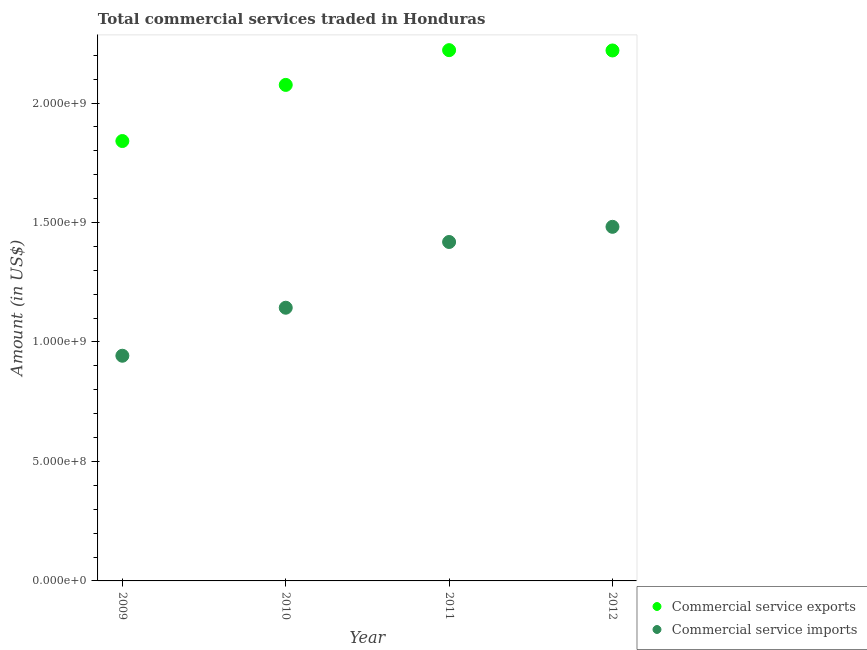How many different coloured dotlines are there?
Ensure brevity in your answer.  2. Is the number of dotlines equal to the number of legend labels?
Ensure brevity in your answer.  Yes. What is the amount of commercial service exports in 2012?
Offer a terse response. 2.22e+09. Across all years, what is the maximum amount of commercial service imports?
Your answer should be very brief. 1.48e+09. Across all years, what is the minimum amount of commercial service imports?
Give a very brief answer. 9.42e+08. In which year was the amount of commercial service exports maximum?
Ensure brevity in your answer.  2011. In which year was the amount of commercial service imports minimum?
Give a very brief answer. 2009. What is the total amount of commercial service imports in the graph?
Offer a very short reply. 4.99e+09. What is the difference between the amount of commercial service imports in 2009 and that in 2012?
Your response must be concise. -5.39e+08. What is the difference between the amount of commercial service exports in 2010 and the amount of commercial service imports in 2012?
Your answer should be very brief. 5.94e+08. What is the average amount of commercial service exports per year?
Your response must be concise. 2.09e+09. In the year 2009, what is the difference between the amount of commercial service exports and amount of commercial service imports?
Your response must be concise. 8.99e+08. In how many years, is the amount of commercial service exports greater than 1400000000 US$?
Your answer should be very brief. 4. What is the ratio of the amount of commercial service exports in 2011 to that in 2012?
Your response must be concise. 1. Is the amount of commercial service exports in 2010 less than that in 2012?
Ensure brevity in your answer.  Yes. Is the difference between the amount of commercial service exports in 2009 and 2012 greater than the difference between the amount of commercial service imports in 2009 and 2012?
Offer a very short reply. Yes. What is the difference between the highest and the second highest amount of commercial service imports?
Your answer should be compact. 6.34e+07. What is the difference between the highest and the lowest amount of commercial service imports?
Keep it short and to the point. 5.39e+08. In how many years, is the amount of commercial service exports greater than the average amount of commercial service exports taken over all years?
Provide a succinct answer. 2. How many dotlines are there?
Make the answer very short. 2. Are the values on the major ticks of Y-axis written in scientific E-notation?
Offer a terse response. Yes. Does the graph contain grids?
Your answer should be very brief. No. Where does the legend appear in the graph?
Give a very brief answer. Bottom right. How many legend labels are there?
Keep it short and to the point. 2. What is the title of the graph?
Offer a very short reply. Total commercial services traded in Honduras. Does "Registered firms" appear as one of the legend labels in the graph?
Give a very brief answer. No. What is the label or title of the Y-axis?
Offer a terse response. Amount (in US$). What is the Amount (in US$) of Commercial service exports in 2009?
Your answer should be very brief. 1.84e+09. What is the Amount (in US$) of Commercial service imports in 2009?
Provide a succinct answer. 9.42e+08. What is the Amount (in US$) in Commercial service exports in 2010?
Your answer should be compact. 2.08e+09. What is the Amount (in US$) in Commercial service imports in 2010?
Provide a succinct answer. 1.14e+09. What is the Amount (in US$) in Commercial service exports in 2011?
Provide a short and direct response. 2.22e+09. What is the Amount (in US$) in Commercial service imports in 2011?
Offer a terse response. 1.42e+09. What is the Amount (in US$) of Commercial service exports in 2012?
Keep it short and to the point. 2.22e+09. What is the Amount (in US$) in Commercial service imports in 2012?
Your answer should be very brief. 1.48e+09. Across all years, what is the maximum Amount (in US$) of Commercial service exports?
Ensure brevity in your answer.  2.22e+09. Across all years, what is the maximum Amount (in US$) in Commercial service imports?
Make the answer very short. 1.48e+09. Across all years, what is the minimum Amount (in US$) in Commercial service exports?
Your response must be concise. 1.84e+09. Across all years, what is the minimum Amount (in US$) in Commercial service imports?
Offer a terse response. 9.42e+08. What is the total Amount (in US$) of Commercial service exports in the graph?
Offer a terse response. 8.36e+09. What is the total Amount (in US$) of Commercial service imports in the graph?
Keep it short and to the point. 4.99e+09. What is the difference between the Amount (in US$) of Commercial service exports in 2009 and that in 2010?
Your answer should be very brief. -2.35e+08. What is the difference between the Amount (in US$) in Commercial service imports in 2009 and that in 2010?
Offer a very short reply. -2.01e+08. What is the difference between the Amount (in US$) of Commercial service exports in 2009 and that in 2011?
Your answer should be very brief. -3.80e+08. What is the difference between the Amount (in US$) in Commercial service imports in 2009 and that in 2011?
Ensure brevity in your answer.  -4.76e+08. What is the difference between the Amount (in US$) of Commercial service exports in 2009 and that in 2012?
Your answer should be very brief. -3.79e+08. What is the difference between the Amount (in US$) in Commercial service imports in 2009 and that in 2012?
Provide a short and direct response. -5.39e+08. What is the difference between the Amount (in US$) in Commercial service exports in 2010 and that in 2011?
Give a very brief answer. -1.45e+08. What is the difference between the Amount (in US$) of Commercial service imports in 2010 and that in 2011?
Your answer should be compact. -2.75e+08. What is the difference between the Amount (in US$) in Commercial service exports in 2010 and that in 2012?
Make the answer very short. -1.44e+08. What is the difference between the Amount (in US$) of Commercial service imports in 2010 and that in 2012?
Keep it short and to the point. -3.39e+08. What is the difference between the Amount (in US$) in Commercial service exports in 2011 and that in 2012?
Provide a short and direct response. 1.30e+06. What is the difference between the Amount (in US$) in Commercial service imports in 2011 and that in 2012?
Your response must be concise. -6.34e+07. What is the difference between the Amount (in US$) of Commercial service exports in 2009 and the Amount (in US$) of Commercial service imports in 2010?
Provide a short and direct response. 6.98e+08. What is the difference between the Amount (in US$) in Commercial service exports in 2009 and the Amount (in US$) in Commercial service imports in 2011?
Provide a short and direct response. 4.22e+08. What is the difference between the Amount (in US$) of Commercial service exports in 2009 and the Amount (in US$) of Commercial service imports in 2012?
Keep it short and to the point. 3.59e+08. What is the difference between the Amount (in US$) in Commercial service exports in 2010 and the Amount (in US$) in Commercial service imports in 2011?
Offer a very short reply. 6.57e+08. What is the difference between the Amount (in US$) in Commercial service exports in 2010 and the Amount (in US$) in Commercial service imports in 2012?
Make the answer very short. 5.94e+08. What is the difference between the Amount (in US$) of Commercial service exports in 2011 and the Amount (in US$) of Commercial service imports in 2012?
Your response must be concise. 7.39e+08. What is the average Amount (in US$) in Commercial service exports per year?
Your answer should be compact. 2.09e+09. What is the average Amount (in US$) of Commercial service imports per year?
Ensure brevity in your answer.  1.25e+09. In the year 2009, what is the difference between the Amount (in US$) in Commercial service exports and Amount (in US$) in Commercial service imports?
Ensure brevity in your answer.  8.99e+08. In the year 2010, what is the difference between the Amount (in US$) in Commercial service exports and Amount (in US$) in Commercial service imports?
Your answer should be very brief. 9.33e+08. In the year 2011, what is the difference between the Amount (in US$) of Commercial service exports and Amount (in US$) of Commercial service imports?
Offer a terse response. 8.03e+08. In the year 2012, what is the difference between the Amount (in US$) of Commercial service exports and Amount (in US$) of Commercial service imports?
Make the answer very short. 7.38e+08. What is the ratio of the Amount (in US$) in Commercial service exports in 2009 to that in 2010?
Provide a short and direct response. 0.89. What is the ratio of the Amount (in US$) in Commercial service imports in 2009 to that in 2010?
Ensure brevity in your answer.  0.82. What is the ratio of the Amount (in US$) of Commercial service exports in 2009 to that in 2011?
Provide a short and direct response. 0.83. What is the ratio of the Amount (in US$) of Commercial service imports in 2009 to that in 2011?
Provide a short and direct response. 0.66. What is the ratio of the Amount (in US$) of Commercial service exports in 2009 to that in 2012?
Offer a terse response. 0.83. What is the ratio of the Amount (in US$) in Commercial service imports in 2009 to that in 2012?
Give a very brief answer. 0.64. What is the ratio of the Amount (in US$) of Commercial service exports in 2010 to that in 2011?
Your response must be concise. 0.93. What is the ratio of the Amount (in US$) of Commercial service imports in 2010 to that in 2011?
Keep it short and to the point. 0.81. What is the ratio of the Amount (in US$) in Commercial service exports in 2010 to that in 2012?
Your answer should be very brief. 0.94. What is the ratio of the Amount (in US$) in Commercial service imports in 2010 to that in 2012?
Provide a short and direct response. 0.77. What is the ratio of the Amount (in US$) of Commercial service imports in 2011 to that in 2012?
Offer a terse response. 0.96. What is the difference between the highest and the second highest Amount (in US$) in Commercial service exports?
Your answer should be compact. 1.30e+06. What is the difference between the highest and the second highest Amount (in US$) in Commercial service imports?
Your answer should be very brief. 6.34e+07. What is the difference between the highest and the lowest Amount (in US$) in Commercial service exports?
Your response must be concise. 3.80e+08. What is the difference between the highest and the lowest Amount (in US$) of Commercial service imports?
Provide a short and direct response. 5.39e+08. 